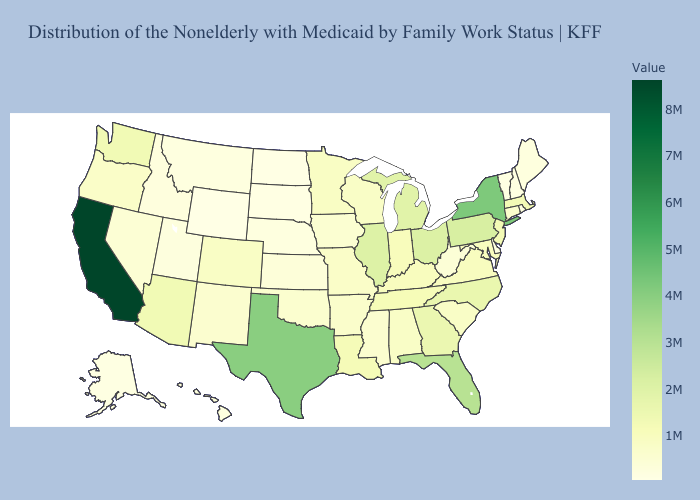Which states have the highest value in the USA?
Answer briefly. California. Which states have the highest value in the USA?
Keep it brief. California. Does New Jersey have a higher value than Delaware?
Short answer required. Yes. Does Ohio have the highest value in the MidWest?
Write a very short answer. Yes. Does Arkansas have the highest value in the USA?
Answer briefly. No. 